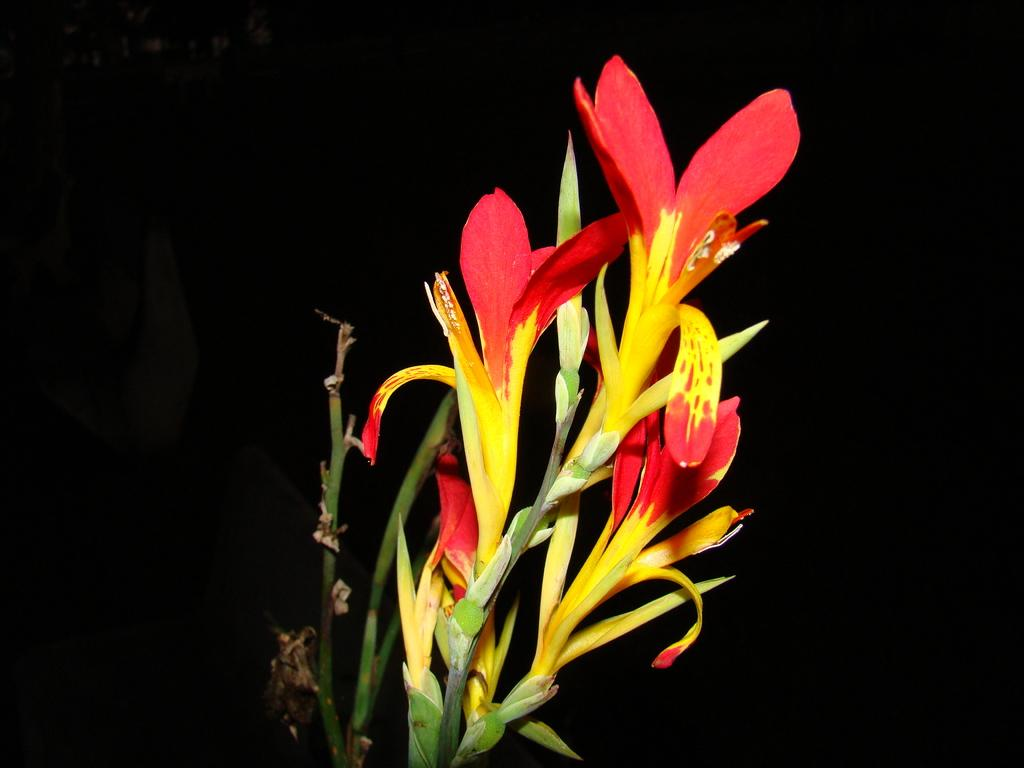What type of plants can be seen in the image? There are flowers in the image. Where are the flowers located in relation to the image? The flowers are located in the front. Who is wearing the crown in the image? There is no crown present in the image. 